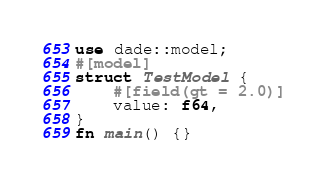Convert code to text. <code><loc_0><loc_0><loc_500><loc_500><_Rust_>use dade::model;
#[model]
struct TestModel {
    #[field(gt = 2.0)]
    value: f64,
}
fn main() {}
</code> 